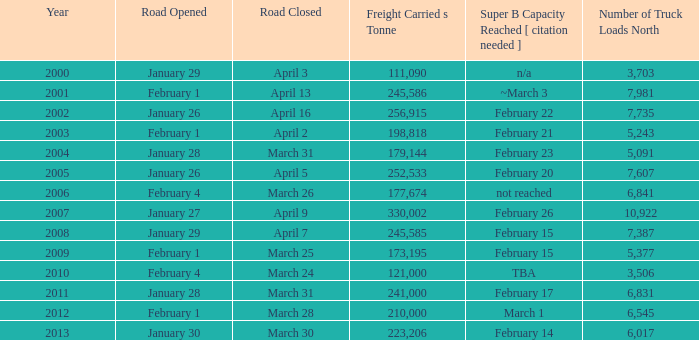What is the smallest amount of freight carried on the road that closed on March 31 and reached super B capacity on February 17 after 2011? None. 